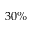<formula> <loc_0><loc_0><loc_500><loc_500>3 0 \%</formula> 